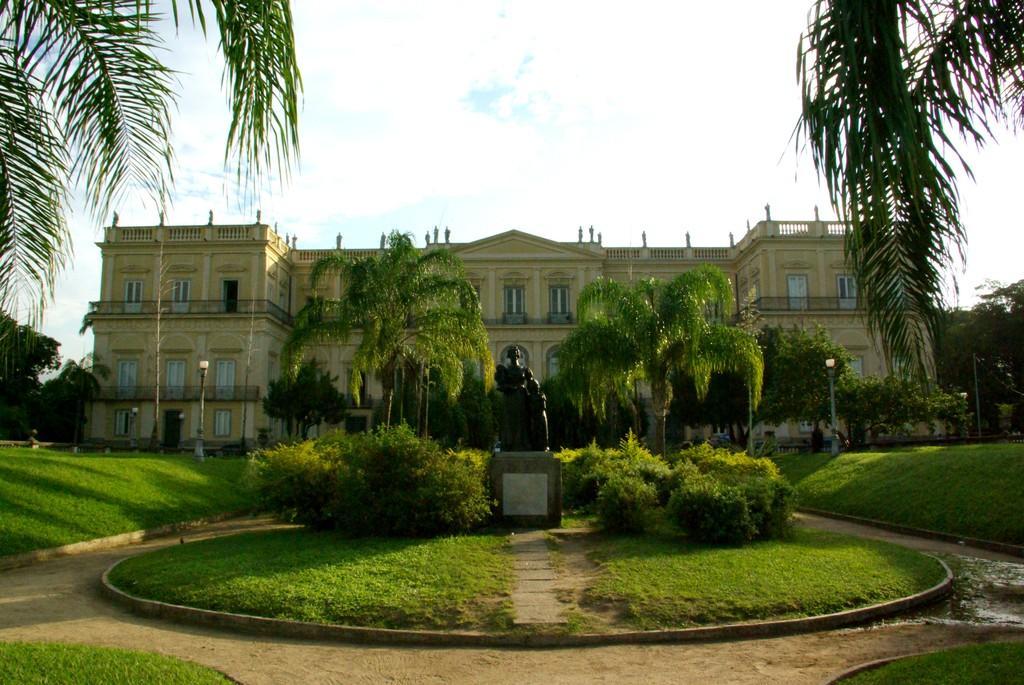Can you describe this image briefly? In the picture I can see a building, plants, the grass, a statue and trees. In the background I can see trees, pole lights, the sky and some other objects on the ground. 